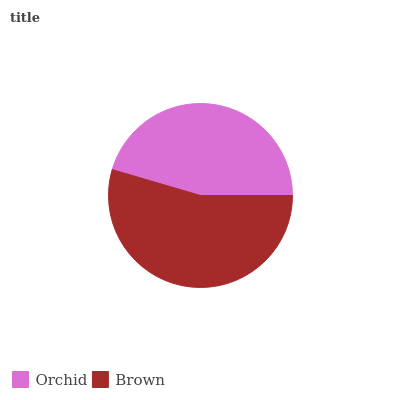Is Orchid the minimum?
Answer yes or no. Yes. Is Brown the maximum?
Answer yes or no. Yes. Is Brown the minimum?
Answer yes or no. No. Is Brown greater than Orchid?
Answer yes or no. Yes. Is Orchid less than Brown?
Answer yes or no. Yes. Is Orchid greater than Brown?
Answer yes or no. No. Is Brown less than Orchid?
Answer yes or no. No. Is Brown the high median?
Answer yes or no. Yes. Is Orchid the low median?
Answer yes or no. Yes. Is Orchid the high median?
Answer yes or no. No. Is Brown the low median?
Answer yes or no. No. 